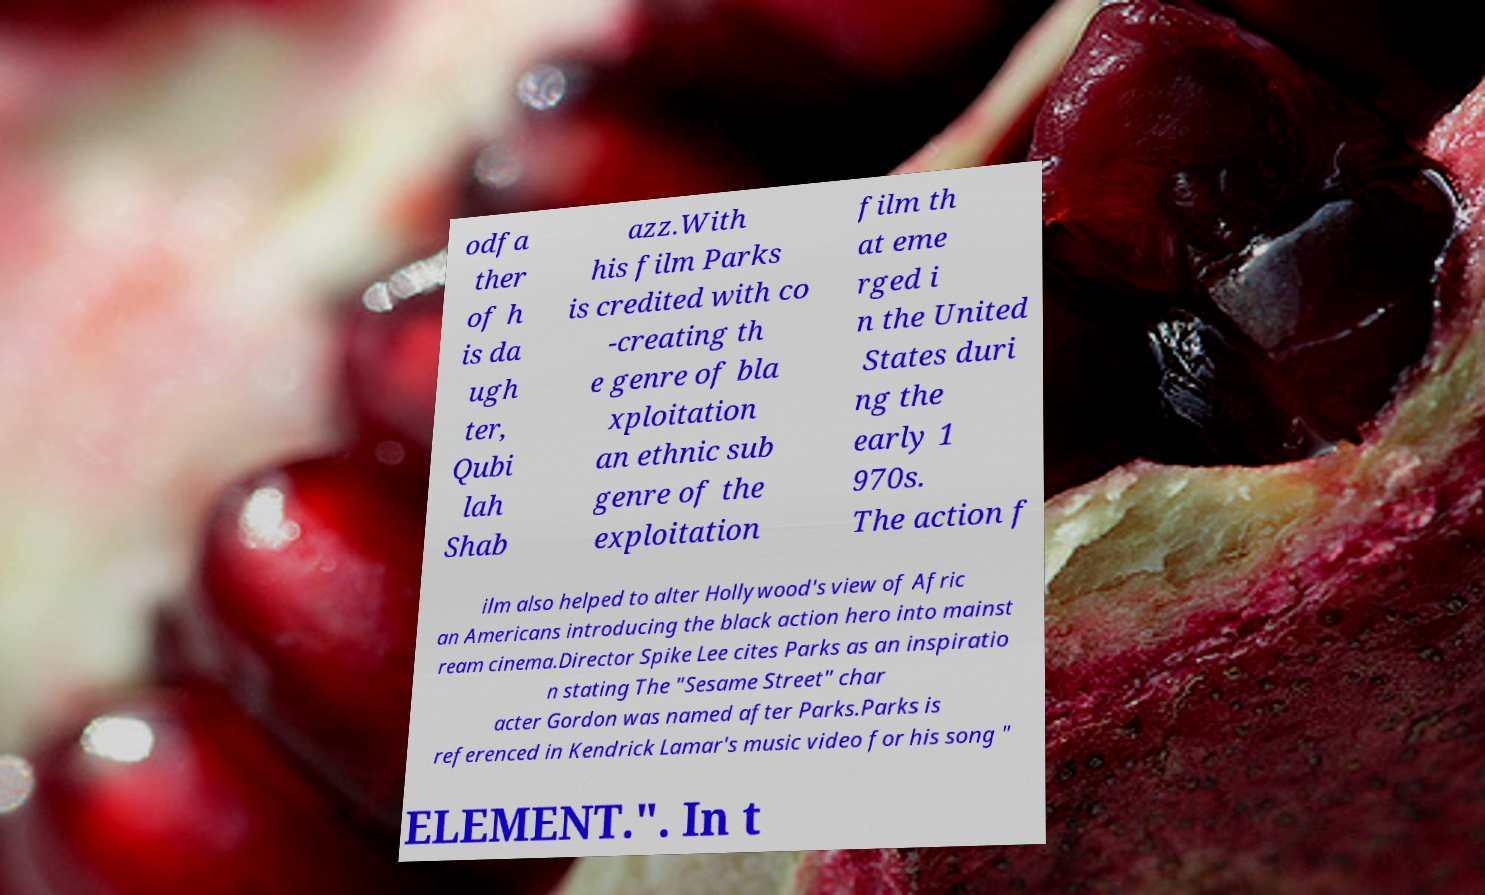For documentation purposes, I need the text within this image transcribed. Could you provide that? odfa ther of h is da ugh ter, Qubi lah Shab azz.With his film Parks is credited with co -creating th e genre of bla xploitation an ethnic sub genre of the exploitation film th at eme rged i n the United States duri ng the early 1 970s. The action f ilm also helped to alter Hollywood's view of Afric an Americans introducing the black action hero into mainst ream cinema.Director Spike Lee cites Parks as an inspiratio n stating The "Sesame Street" char acter Gordon was named after Parks.Parks is referenced in Kendrick Lamar's music video for his song " ELEMENT.". In t 